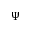Convert formula to latex. <formula><loc_0><loc_0><loc_500><loc_500>\Psi</formula> 